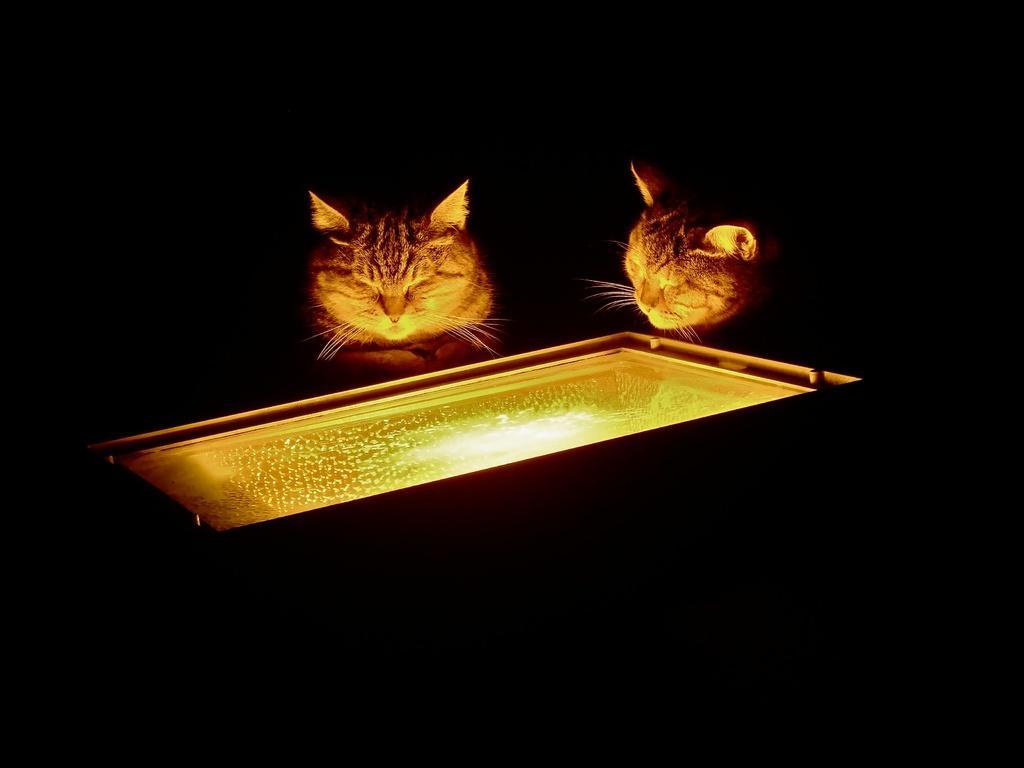In one or two sentences, can you explain what this image depicts? In this image we can see two cats looking into an object, in an object we can see the light and the background is dark. 